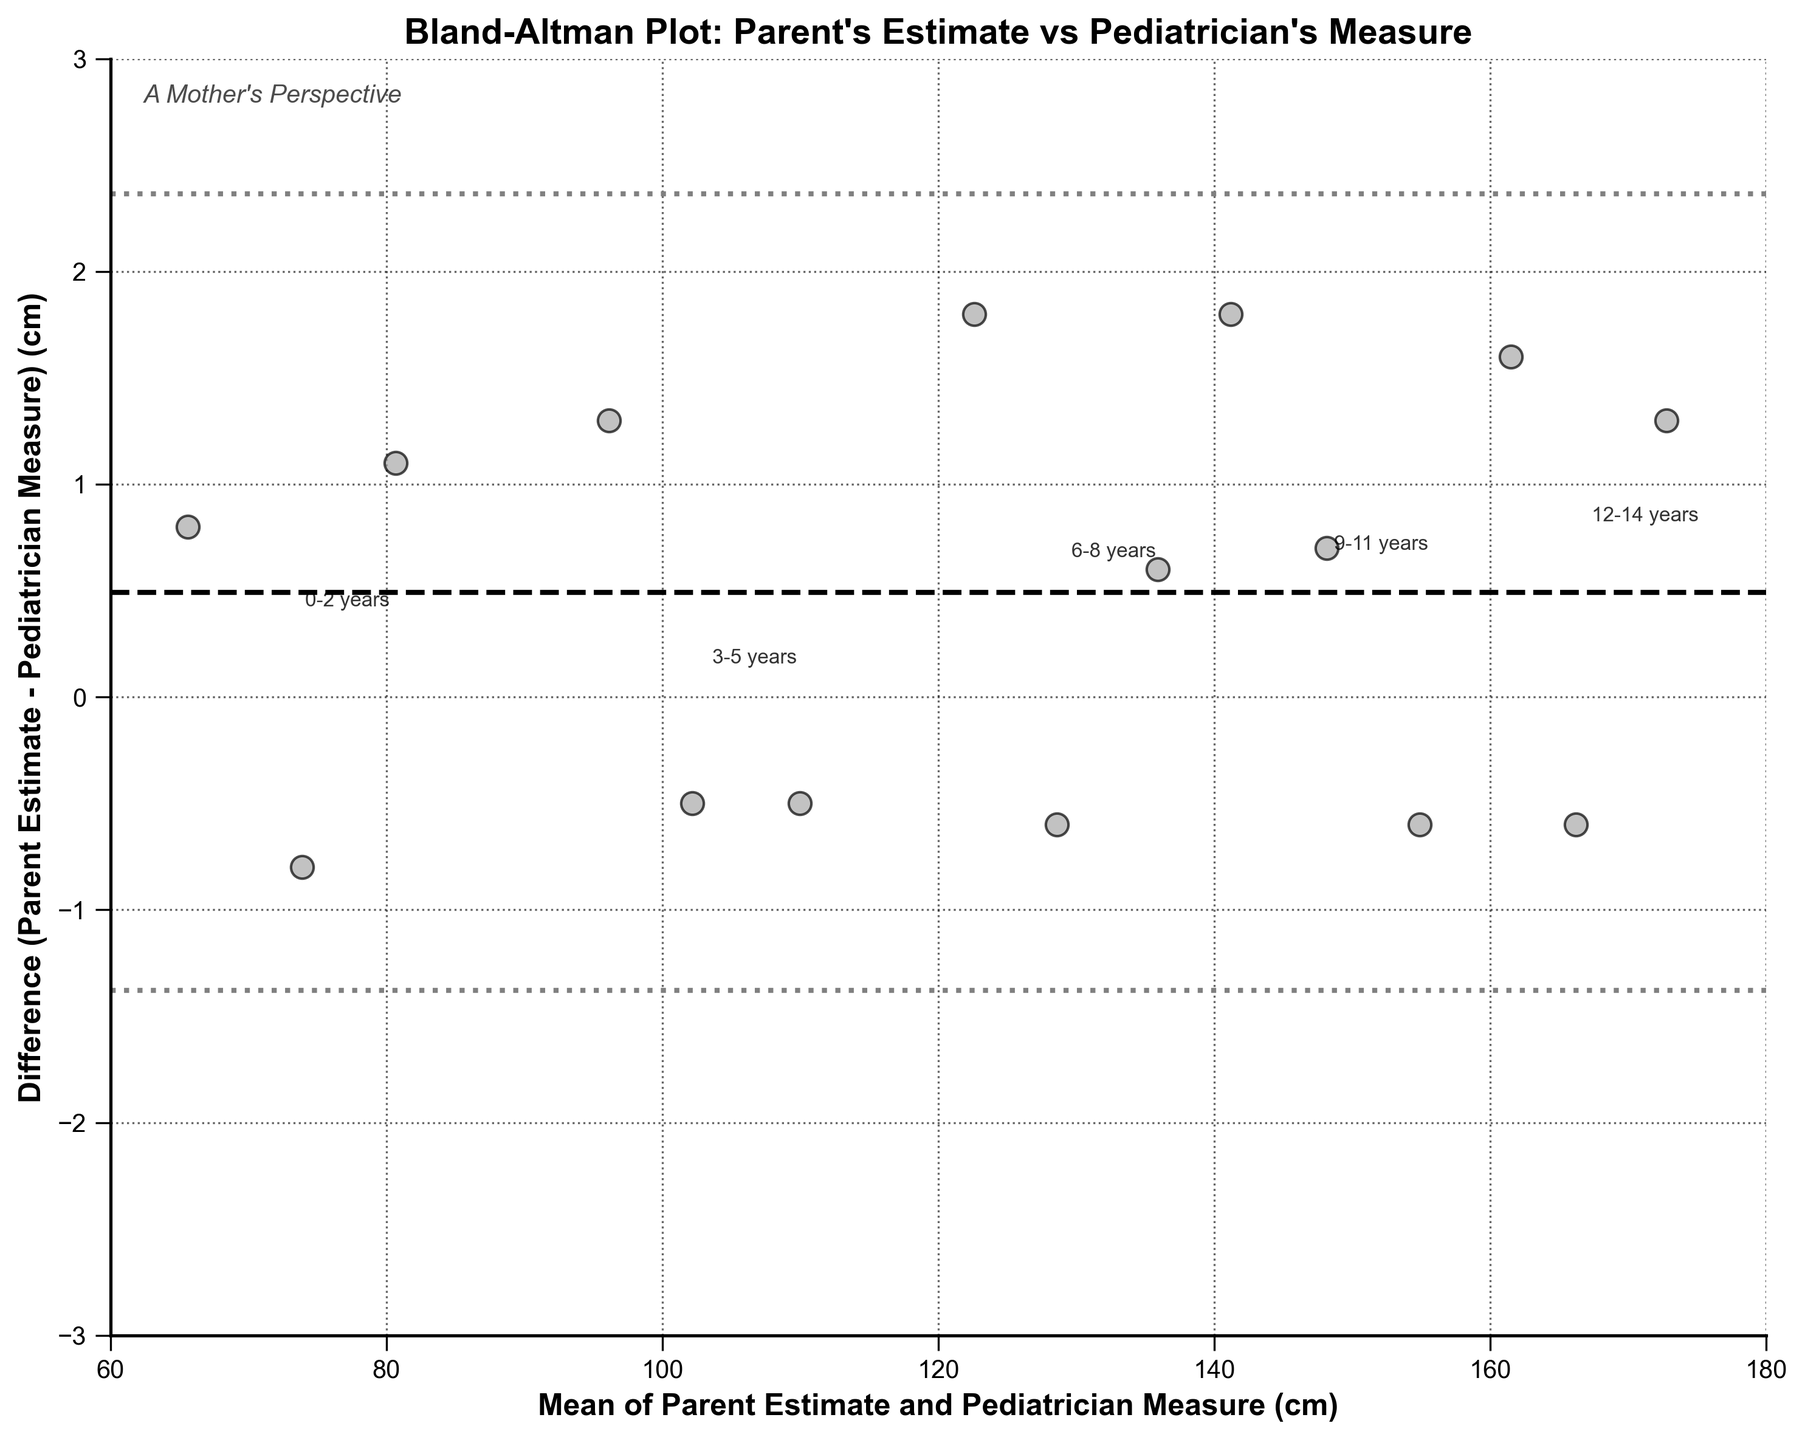What's the title of the figure? The title of the figure is prominently displayed at the top. It reads "Bland-Altman Plot: Parent's Estimate vs Pediatrician's Measure".
Answer: Bland-Altman Plot: Parent's Estimate vs Pediatrician's Measure What does the y-axis represent? The y-axis label is "Difference (Parent Estimate - Pediatrician Measure) (cm)". It indicates the difference between the parent's estimate and the pediatrician's measure of the child's height.
Answer: Difference (Parent Estimate - Pediatrician Measure) (cm) What is the mean difference between parent estimates and pediatrician measures? The mean difference can be identified by the horizontal dashed line in the plot. The annotation on this line indicates the value of the mean difference.
Answer: Approximately 0.43 cm What is the range of the x-axis? The x-axis range can be identified by the axis limits. The plot shows the range from 60 cm to 180 cm.
Answer: 60 to 180 cm Which age group has the largest average height difference from the parent's estimate to the pediatrician's measure? By looking at the placement of the labeled age groups, the age group 6-8 years shows the largest average height difference from the parent's estimate to the pediatrician's measure.
Answer: 6-8 years Is the variability in differences consistent across different age groups? The variability in differences can be assessed by observing the spread of data points within each age group's cluster. Some age groups, like 0-2 years and 12-14 years, show more spread, indicating less consistent differences compared to others.
Answer: No Which age group shows the smallest average difference between parent estimates and pediatrician measures? By comparing the cluster of labeled points for each age group, 3-5 years appears to be closest to the mean difference line, indicating the smallest average difference.
Answer: 3-5 years How many data points are there in total? The total number of points can be counted visually. By counting each data marker, we see there are 15 data points in total.
Answer: 15 Does the mean difference indicate that parents consistently overestimate or underestimate their child’s height? The mean difference line is slightly above zero, indicating that, on average, parents slightly underestimate their child’s height.
Answer: Underestimate 